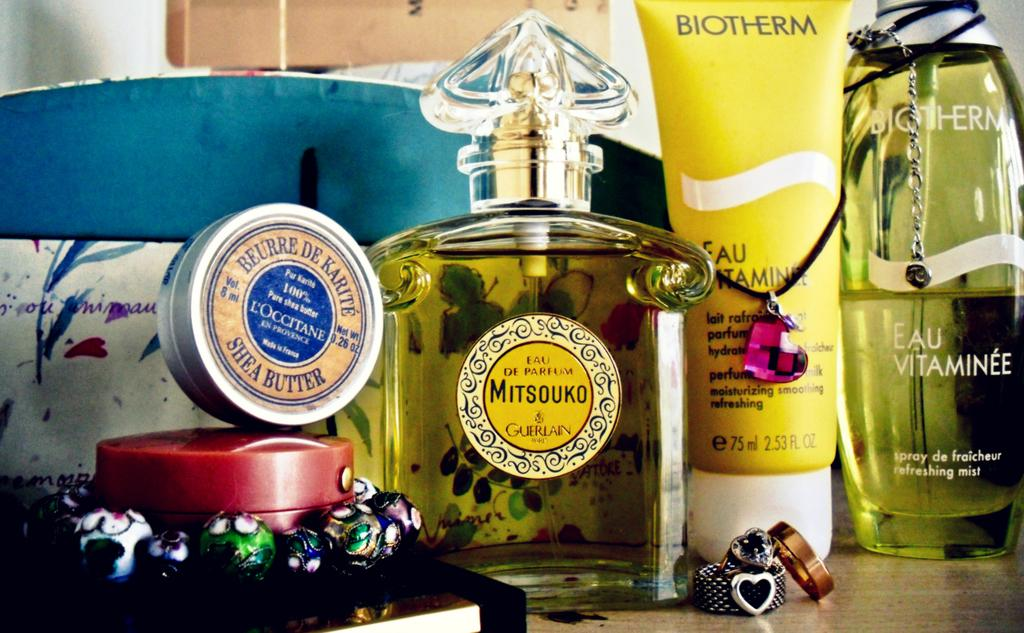Provide a one-sentence caption for the provided image. Beauty products laying on a shelf, one of them being shea butter in a metal tin. 